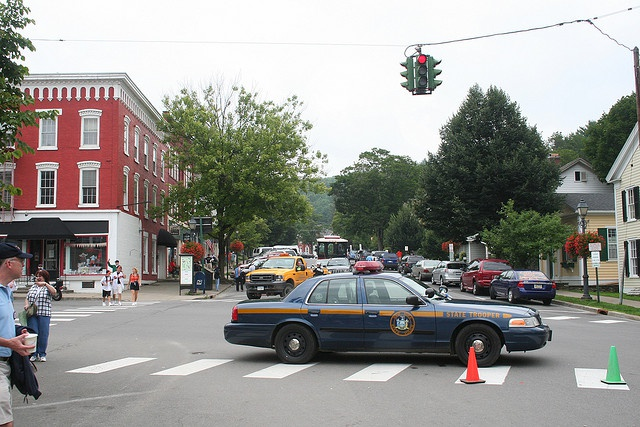Describe the objects in this image and their specific colors. I can see car in white, black, darkgray, gray, and navy tones, people in white, darkgray, black, brown, and gray tones, car in white, black, gray, darkgray, and khaki tones, truck in white, black, gray, khaki, and lightblue tones, and car in white, black, gray, darkgray, and navy tones in this image. 